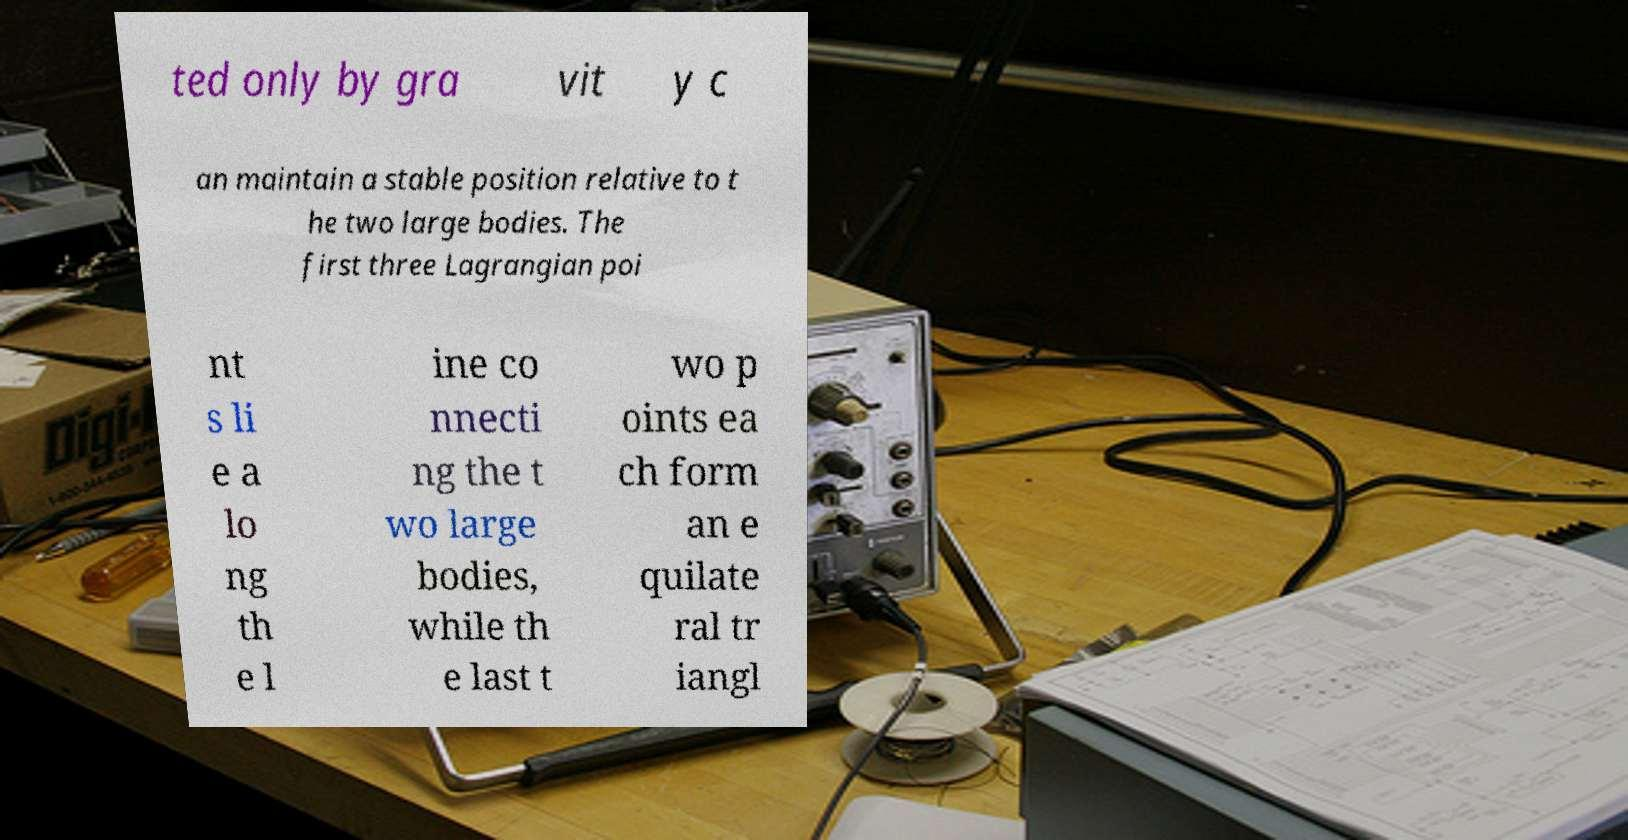I need the written content from this picture converted into text. Can you do that? ted only by gra vit y c an maintain a stable position relative to t he two large bodies. The first three Lagrangian poi nt s li e a lo ng th e l ine co nnecti ng the t wo large bodies, while th e last t wo p oints ea ch form an e quilate ral tr iangl 